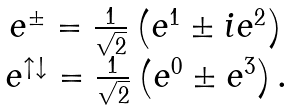<formula> <loc_0><loc_0><loc_500><loc_500>\begin{array} { c } e ^ { \pm } = \frac { 1 } { \sqrt { 2 } } \left ( e ^ { 1 } \pm i e ^ { 2 } \right ) \\ e ^ { \uparrow \downarrow } = \frac { 1 } { \sqrt { 2 } } \left ( e ^ { 0 } \pm e ^ { 3 } \right ) \text {.} \end{array}</formula> 